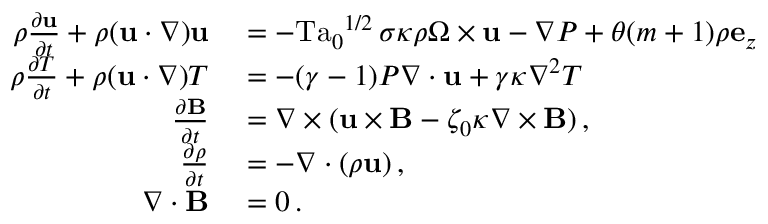<formula> <loc_0><loc_0><loc_500><loc_500>\begin{array} { r l } { \rho \frac { \partial u } { \partial t } + \rho ( u \cdot \nabla ) u } & = - { T a _ { 0 } } ^ { 1 / 2 } \, \sigma \kappa \rho \Omega \times u - \nabla P + \theta ( m + 1 ) \rho e _ { z } } \\ { \rho \frac { \partial T } { \partial t } + \rho ( u \cdot \nabla ) T } & = - ( \gamma - 1 ) P \nabla \cdot u + \gamma \kappa \nabla ^ { 2 } T } \\ { \frac { \partial B } { \partial t } } & = \nabla \times ( u \times B - \zeta _ { 0 } \kappa \nabla \times B ) \, , } \\ { \frac { \partial \rho } { \partial t } } & = - \nabla \cdot ( \rho u ) \, , } \\ { \nabla \cdot B } & = 0 \, . } \end{array}</formula> 